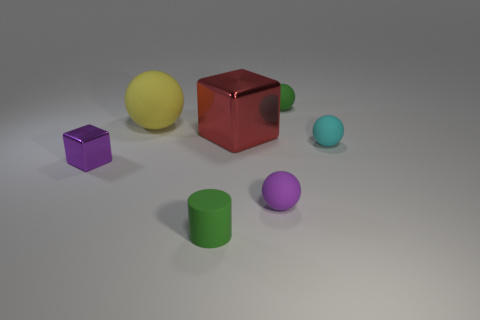Does the red metallic cube have the same size as the rubber cylinder?
Keep it short and to the point. No. How many objects are tiny cubes or big blue metallic blocks?
Ensure brevity in your answer.  1. The small rubber thing that is behind the large thing that is left of the tiny green object that is in front of the purple matte sphere is what shape?
Keep it short and to the point. Sphere. Is the material of the cube in front of the small cyan rubber object the same as the purple thing that is right of the yellow rubber sphere?
Give a very brief answer. No. What is the material of the tiny purple object that is the same shape as the big red metallic object?
Offer a very short reply. Metal. Are there any other things that have the same size as the yellow matte thing?
Your answer should be compact. Yes. There is a big yellow thing that is behind the small matte cylinder; does it have the same shape as the small green object behind the big sphere?
Provide a succinct answer. Yes. Is the number of tiny metal objects right of the purple block less than the number of large red metallic blocks in front of the red shiny object?
Keep it short and to the point. No. What number of other things are there of the same shape as the large yellow matte thing?
Make the answer very short. 3. The red thing that is made of the same material as the purple block is what shape?
Your response must be concise. Cube. 